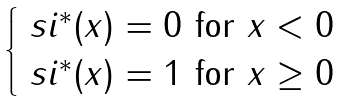Convert formula to latex. <formula><loc_0><loc_0><loc_500><loc_500>\begin{cases} \ s i ^ { * } ( x ) = 0 \ \text {for} \ x < 0 \\ \ s i ^ { * } ( x ) = 1 \ \text {for} \ x \geq 0 \end{cases}</formula> 